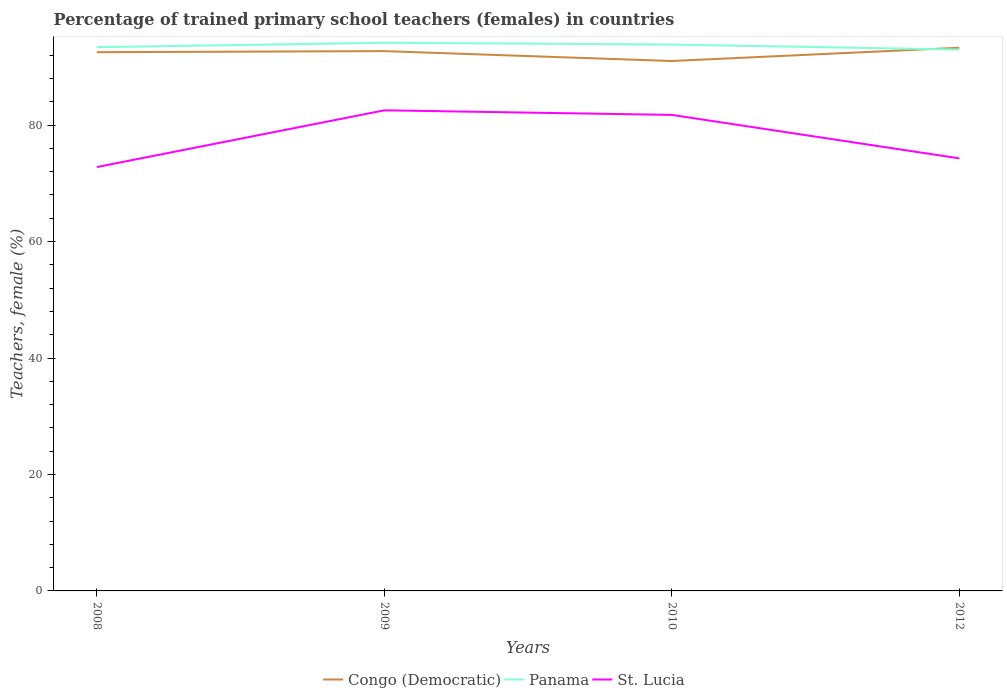How many different coloured lines are there?
Provide a short and direct response. 3. Does the line corresponding to Panama intersect with the line corresponding to St. Lucia?
Provide a succinct answer. No. Is the number of lines equal to the number of legend labels?
Make the answer very short. Yes. Across all years, what is the maximum percentage of trained primary school teachers (females) in Congo (Democratic)?
Give a very brief answer. 91.01. In which year was the percentage of trained primary school teachers (females) in Congo (Democratic) maximum?
Your response must be concise. 2010. What is the total percentage of trained primary school teachers (females) in Congo (Democratic) in the graph?
Your answer should be very brief. -0.76. What is the difference between the highest and the second highest percentage of trained primary school teachers (females) in Panama?
Provide a short and direct response. 1.17. How many lines are there?
Offer a terse response. 3. What is the difference between two consecutive major ticks on the Y-axis?
Keep it short and to the point. 20. Does the graph contain any zero values?
Your answer should be compact. No. Does the graph contain grids?
Your response must be concise. No. Where does the legend appear in the graph?
Ensure brevity in your answer.  Bottom center. How are the legend labels stacked?
Provide a short and direct response. Horizontal. What is the title of the graph?
Give a very brief answer. Percentage of trained primary school teachers (females) in countries. What is the label or title of the Y-axis?
Make the answer very short. Teachers, female (%). What is the Teachers, female (%) in Congo (Democratic) in 2008?
Keep it short and to the point. 92.52. What is the Teachers, female (%) in Panama in 2008?
Give a very brief answer. 93.38. What is the Teachers, female (%) in St. Lucia in 2008?
Give a very brief answer. 72.79. What is the Teachers, female (%) in Congo (Democratic) in 2009?
Your answer should be very brief. 92.71. What is the Teachers, female (%) of Panama in 2009?
Provide a short and direct response. 94.14. What is the Teachers, female (%) in St. Lucia in 2009?
Make the answer very short. 82.54. What is the Teachers, female (%) in Congo (Democratic) in 2010?
Provide a succinct answer. 91.01. What is the Teachers, female (%) of Panama in 2010?
Offer a very short reply. 93.84. What is the Teachers, female (%) of St. Lucia in 2010?
Provide a short and direct response. 81.75. What is the Teachers, female (%) in Congo (Democratic) in 2012?
Keep it short and to the point. 93.29. What is the Teachers, female (%) of Panama in 2012?
Your response must be concise. 92.97. What is the Teachers, female (%) in St. Lucia in 2012?
Your answer should be compact. 74.29. Across all years, what is the maximum Teachers, female (%) in Congo (Democratic)?
Ensure brevity in your answer.  93.29. Across all years, what is the maximum Teachers, female (%) in Panama?
Keep it short and to the point. 94.14. Across all years, what is the maximum Teachers, female (%) of St. Lucia?
Offer a terse response. 82.54. Across all years, what is the minimum Teachers, female (%) of Congo (Democratic)?
Make the answer very short. 91.01. Across all years, what is the minimum Teachers, female (%) in Panama?
Provide a succinct answer. 92.97. Across all years, what is the minimum Teachers, female (%) of St. Lucia?
Provide a succinct answer. 72.79. What is the total Teachers, female (%) of Congo (Democratic) in the graph?
Your answer should be very brief. 369.52. What is the total Teachers, female (%) in Panama in the graph?
Your answer should be very brief. 374.33. What is the total Teachers, female (%) of St. Lucia in the graph?
Give a very brief answer. 311.37. What is the difference between the Teachers, female (%) in Congo (Democratic) in 2008 and that in 2009?
Offer a very short reply. -0.18. What is the difference between the Teachers, female (%) in Panama in 2008 and that in 2009?
Keep it short and to the point. -0.75. What is the difference between the Teachers, female (%) in St. Lucia in 2008 and that in 2009?
Offer a very short reply. -9.75. What is the difference between the Teachers, female (%) in Congo (Democratic) in 2008 and that in 2010?
Keep it short and to the point. 1.51. What is the difference between the Teachers, female (%) in Panama in 2008 and that in 2010?
Keep it short and to the point. -0.45. What is the difference between the Teachers, female (%) of St. Lucia in 2008 and that in 2010?
Provide a succinct answer. -8.96. What is the difference between the Teachers, female (%) in Congo (Democratic) in 2008 and that in 2012?
Give a very brief answer. -0.76. What is the difference between the Teachers, female (%) in Panama in 2008 and that in 2012?
Keep it short and to the point. 0.41. What is the difference between the Teachers, female (%) of St. Lucia in 2008 and that in 2012?
Your answer should be compact. -1.49. What is the difference between the Teachers, female (%) in Congo (Democratic) in 2009 and that in 2010?
Your answer should be very brief. 1.7. What is the difference between the Teachers, female (%) in Panama in 2009 and that in 2010?
Offer a very short reply. 0.3. What is the difference between the Teachers, female (%) in St. Lucia in 2009 and that in 2010?
Provide a short and direct response. 0.79. What is the difference between the Teachers, female (%) of Congo (Democratic) in 2009 and that in 2012?
Make the answer very short. -0.58. What is the difference between the Teachers, female (%) of Panama in 2009 and that in 2012?
Your answer should be compact. 1.17. What is the difference between the Teachers, female (%) in St. Lucia in 2009 and that in 2012?
Keep it short and to the point. 8.25. What is the difference between the Teachers, female (%) of Congo (Democratic) in 2010 and that in 2012?
Ensure brevity in your answer.  -2.28. What is the difference between the Teachers, female (%) in Panama in 2010 and that in 2012?
Give a very brief answer. 0.87. What is the difference between the Teachers, female (%) of St. Lucia in 2010 and that in 2012?
Provide a short and direct response. 7.47. What is the difference between the Teachers, female (%) in Congo (Democratic) in 2008 and the Teachers, female (%) in Panama in 2009?
Ensure brevity in your answer.  -1.61. What is the difference between the Teachers, female (%) of Congo (Democratic) in 2008 and the Teachers, female (%) of St. Lucia in 2009?
Your answer should be very brief. 9.98. What is the difference between the Teachers, female (%) of Panama in 2008 and the Teachers, female (%) of St. Lucia in 2009?
Offer a very short reply. 10.84. What is the difference between the Teachers, female (%) of Congo (Democratic) in 2008 and the Teachers, female (%) of Panama in 2010?
Your answer should be very brief. -1.31. What is the difference between the Teachers, female (%) in Congo (Democratic) in 2008 and the Teachers, female (%) in St. Lucia in 2010?
Provide a short and direct response. 10.77. What is the difference between the Teachers, female (%) in Panama in 2008 and the Teachers, female (%) in St. Lucia in 2010?
Your response must be concise. 11.63. What is the difference between the Teachers, female (%) of Congo (Democratic) in 2008 and the Teachers, female (%) of Panama in 2012?
Your answer should be very brief. -0.45. What is the difference between the Teachers, female (%) of Congo (Democratic) in 2008 and the Teachers, female (%) of St. Lucia in 2012?
Your answer should be very brief. 18.24. What is the difference between the Teachers, female (%) of Panama in 2008 and the Teachers, female (%) of St. Lucia in 2012?
Your response must be concise. 19.1. What is the difference between the Teachers, female (%) in Congo (Democratic) in 2009 and the Teachers, female (%) in Panama in 2010?
Provide a short and direct response. -1.13. What is the difference between the Teachers, female (%) in Congo (Democratic) in 2009 and the Teachers, female (%) in St. Lucia in 2010?
Your answer should be very brief. 10.95. What is the difference between the Teachers, female (%) in Panama in 2009 and the Teachers, female (%) in St. Lucia in 2010?
Make the answer very short. 12.39. What is the difference between the Teachers, female (%) in Congo (Democratic) in 2009 and the Teachers, female (%) in Panama in 2012?
Give a very brief answer. -0.26. What is the difference between the Teachers, female (%) of Congo (Democratic) in 2009 and the Teachers, female (%) of St. Lucia in 2012?
Ensure brevity in your answer.  18.42. What is the difference between the Teachers, female (%) of Panama in 2009 and the Teachers, female (%) of St. Lucia in 2012?
Give a very brief answer. 19.85. What is the difference between the Teachers, female (%) in Congo (Democratic) in 2010 and the Teachers, female (%) in Panama in 2012?
Provide a succinct answer. -1.96. What is the difference between the Teachers, female (%) of Congo (Democratic) in 2010 and the Teachers, female (%) of St. Lucia in 2012?
Ensure brevity in your answer.  16.72. What is the difference between the Teachers, female (%) of Panama in 2010 and the Teachers, female (%) of St. Lucia in 2012?
Your response must be concise. 19.55. What is the average Teachers, female (%) in Congo (Democratic) per year?
Ensure brevity in your answer.  92.38. What is the average Teachers, female (%) in Panama per year?
Your answer should be compact. 93.58. What is the average Teachers, female (%) in St. Lucia per year?
Offer a very short reply. 77.84. In the year 2008, what is the difference between the Teachers, female (%) of Congo (Democratic) and Teachers, female (%) of Panama?
Provide a succinct answer. -0.86. In the year 2008, what is the difference between the Teachers, female (%) of Congo (Democratic) and Teachers, female (%) of St. Lucia?
Make the answer very short. 19.73. In the year 2008, what is the difference between the Teachers, female (%) in Panama and Teachers, female (%) in St. Lucia?
Offer a very short reply. 20.59. In the year 2009, what is the difference between the Teachers, female (%) in Congo (Democratic) and Teachers, female (%) in Panama?
Your answer should be very brief. -1.43. In the year 2009, what is the difference between the Teachers, female (%) of Congo (Democratic) and Teachers, female (%) of St. Lucia?
Provide a short and direct response. 10.17. In the year 2009, what is the difference between the Teachers, female (%) of Panama and Teachers, female (%) of St. Lucia?
Keep it short and to the point. 11.6. In the year 2010, what is the difference between the Teachers, female (%) of Congo (Democratic) and Teachers, female (%) of Panama?
Provide a succinct answer. -2.83. In the year 2010, what is the difference between the Teachers, female (%) in Congo (Democratic) and Teachers, female (%) in St. Lucia?
Ensure brevity in your answer.  9.26. In the year 2010, what is the difference between the Teachers, female (%) of Panama and Teachers, female (%) of St. Lucia?
Your answer should be compact. 12.08. In the year 2012, what is the difference between the Teachers, female (%) in Congo (Democratic) and Teachers, female (%) in Panama?
Your response must be concise. 0.32. In the year 2012, what is the difference between the Teachers, female (%) in Congo (Democratic) and Teachers, female (%) in St. Lucia?
Offer a terse response. 19. In the year 2012, what is the difference between the Teachers, female (%) of Panama and Teachers, female (%) of St. Lucia?
Make the answer very short. 18.68. What is the ratio of the Teachers, female (%) of Congo (Democratic) in 2008 to that in 2009?
Your response must be concise. 1. What is the ratio of the Teachers, female (%) of St. Lucia in 2008 to that in 2009?
Give a very brief answer. 0.88. What is the ratio of the Teachers, female (%) of Congo (Democratic) in 2008 to that in 2010?
Your answer should be very brief. 1.02. What is the ratio of the Teachers, female (%) of St. Lucia in 2008 to that in 2010?
Give a very brief answer. 0.89. What is the ratio of the Teachers, female (%) of Panama in 2008 to that in 2012?
Offer a very short reply. 1. What is the ratio of the Teachers, female (%) of St. Lucia in 2008 to that in 2012?
Keep it short and to the point. 0.98. What is the ratio of the Teachers, female (%) of Congo (Democratic) in 2009 to that in 2010?
Provide a short and direct response. 1.02. What is the ratio of the Teachers, female (%) in St. Lucia in 2009 to that in 2010?
Provide a succinct answer. 1.01. What is the ratio of the Teachers, female (%) in Panama in 2009 to that in 2012?
Your response must be concise. 1.01. What is the ratio of the Teachers, female (%) in St. Lucia in 2009 to that in 2012?
Your answer should be compact. 1.11. What is the ratio of the Teachers, female (%) of Congo (Democratic) in 2010 to that in 2012?
Give a very brief answer. 0.98. What is the ratio of the Teachers, female (%) of Panama in 2010 to that in 2012?
Offer a very short reply. 1.01. What is the ratio of the Teachers, female (%) of St. Lucia in 2010 to that in 2012?
Keep it short and to the point. 1.1. What is the difference between the highest and the second highest Teachers, female (%) in Congo (Democratic)?
Make the answer very short. 0.58. What is the difference between the highest and the second highest Teachers, female (%) in Panama?
Give a very brief answer. 0.3. What is the difference between the highest and the second highest Teachers, female (%) of St. Lucia?
Offer a terse response. 0.79. What is the difference between the highest and the lowest Teachers, female (%) of Congo (Democratic)?
Provide a succinct answer. 2.28. What is the difference between the highest and the lowest Teachers, female (%) of Panama?
Give a very brief answer. 1.17. What is the difference between the highest and the lowest Teachers, female (%) in St. Lucia?
Provide a short and direct response. 9.75. 